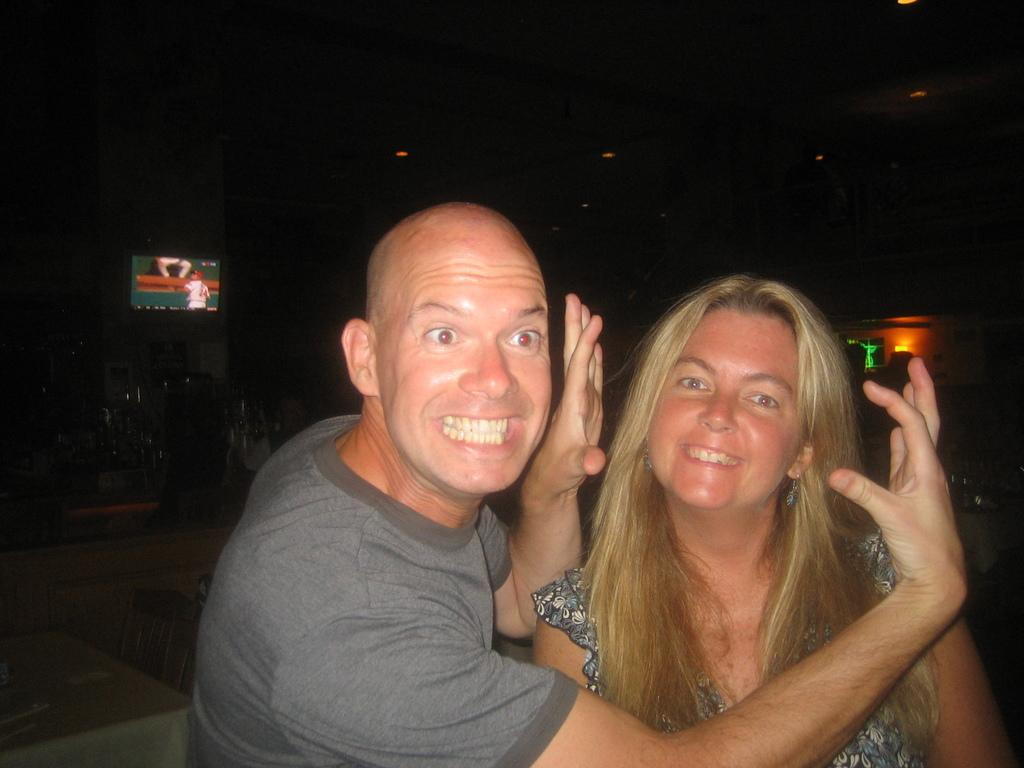How many people are visible in the image? There are two people standing in the front of the image. What can be seen in the background of the image? There is a television and a light in the background of the image. What type of animals can be seen at the zoo in the image? There is no zoo present in the image, so it is not possible to determine what, if any, animals might be seen. 